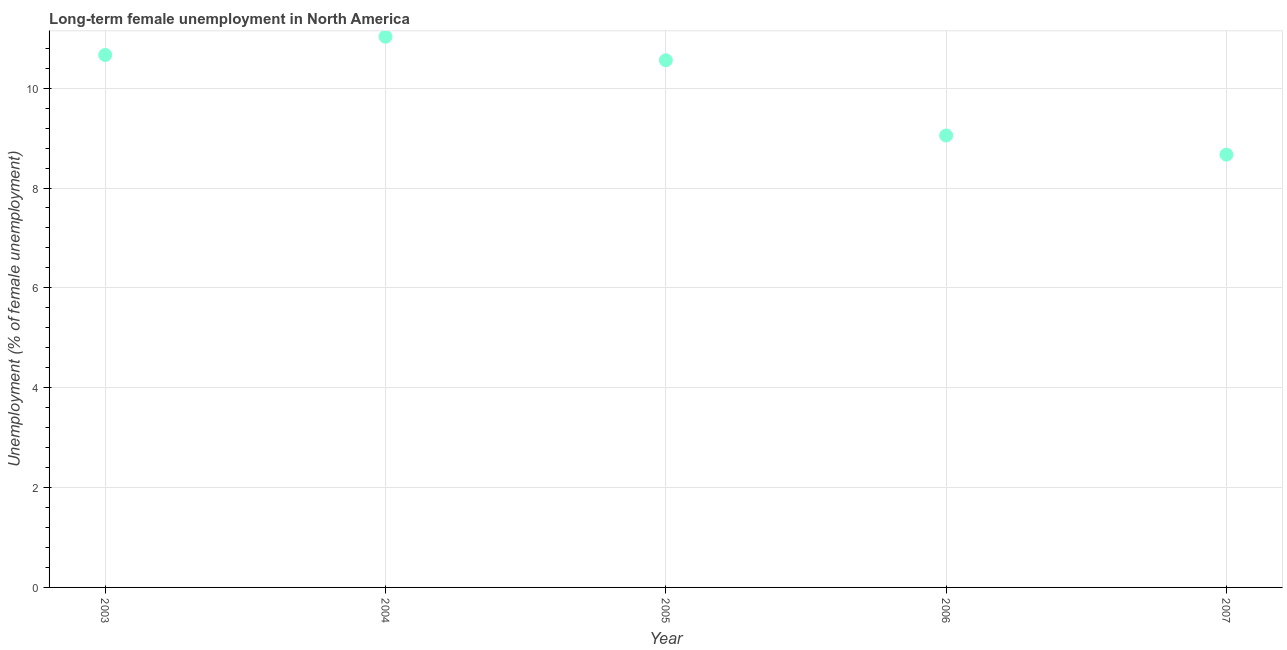What is the long-term female unemployment in 2004?
Offer a terse response. 11.03. Across all years, what is the maximum long-term female unemployment?
Your answer should be compact. 11.03. Across all years, what is the minimum long-term female unemployment?
Give a very brief answer. 8.67. In which year was the long-term female unemployment maximum?
Give a very brief answer. 2004. What is the sum of the long-term female unemployment?
Make the answer very short. 49.97. What is the difference between the long-term female unemployment in 2004 and 2005?
Provide a succinct answer. 0.47. What is the average long-term female unemployment per year?
Offer a terse response. 9.99. What is the median long-term female unemployment?
Make the answer very short. 10.56. In how many years, is the long-term female unemployment greater than 4 %?
Offer a terse response. 5. Do a majority of the years between 2007 and 2004 (inclusive) have long-term female unemployment greater than 4.4 %?
Make the answer very short. Yes. What is the ratio of the long-term female unemployment in 2004 to that in 2007?
Your response must be concise. 1.27. Is the difference between the long-term female unemployment in 2003 and 2007 greater than the difference between any two years?
Make the answer very short. No. What is the difference between the highest and the second highest long-term female unemployment?
Offer a very short reply. 0.37. Is the sum of the long-term female unemployment in 2003 and 2004 greater than the maximum long-term female unemployment across all years?
Keep it short and to the point. Yes. What is the difference between the highest and the lowest long-term female unemployment?
Your answer should be very brief. 2.36. Does the long-term female unemployment monotonically increase over the years?
Keep it short and to the point. No. How many years are there in the graph?
Provide a succinct answer. 5. What is the difference between two consecutive major ticks on the Y-axis?
Your answer should be compact. 2. Does the graph contain grids?
Provide a succinct answer. Yes. What is the title of the graph?
Provide a short and direct response. Long-term female unemployment in North America. What is the label or title of the X-axis?
Your answer should be compact. Year. What is the label or title of the Y-axis?
Give a very brief answer. Unemployment (% of female unemployment). What is the Unemployment (% of female unemployment) in 2003?
Offer a very short reply. 10.66. What is the Unemployment (% of female unemployment) in 2004?
Keep it short and to the point. 11.03. What is the Unemployment (% of female unemployment) in 2005?
Keep it short and to the point. 10.56. What is the Unemployment (% of female unemployment) in 2006?
Your answer should be very brief. 9.05. What is the Unemployment (% of female unemployment) in 2007?
Your answer should be very brief. 8.67. What is the difference between the Unemployment (% of female unemployment) in 2003 and 2004?
Offer a terse response. -0.37. What is the difference between the Unemployment (% of female unemployment) in 2003 and 2005?
Offer a terse response. 0.11. What is the difference between the Unemployment (% of female unemployment) in 2003 and 2006?
Offer a terse response. 1.61. What is the difference between the Unemployment (% of female unemployment) in 2003 and 2007?
Keep it short and to the point. 2. What is the difference between the Unemployment (% of female unemployment) in 2004 and 2005?
Give a very brief answer. 0.47. What is the difference between the Unemployment (% of female unemployment) in 2004 and 2006?
Give a very brief answer. 1.98. What is the difference between the Unemployment (% of female unemployment) in 2004 and 2007?
Give a very brief answer. 2.36. What is the difference between the Unemployment (% of female unemployment) in 2005 and 2006?
Your answer should be compact. 1.51. What is the difference between the Unemployment (% of female unemployment) in 2005 and 2007?
Keep it short and to the point. 1.89. What is the difference between the Unemployment (% of female unemployment) in 2006 and 2007?
Give a very brief answer. 0.38. What is the ratio of the Unemployment (% of female unemployment) in 2003 to that in 2005?
Ensure brevity in your answer.  1.01. What is the ratio of the Unemployment (% of female unemployment) in 2003 to that in 2006?
Give a very brief answer. 1.18. What is the ratio of the Unemployment (% of female unemployment) in 2003 to that in 2007?
Provide a succinct answer. 1.23. What is the ratio of the Unemployment (% of female unemployment) in 2004 to that in 2005?
Ensure brevity in your answer.  1.04. What is the ratio of the Unemployment (% of female unemployment) in 2004 to that in 2006?
Ensure brevity in your answer.  1.22. What is the ratio of the Unemployment (% of female unemployment) in 2004 to that in 2007?
Provide a short and direct response. 1.27. What is the ratio of the Unemployment (% of female unemployment) in 2005 to that in 2006?
Your response must be concise. 1.17. What is the ratio of the Unemployment (% of female unemployment) in 2005 to that in 2007?
Your answer should be compact. 1.22. What is the ratio of the Unemployment (% of female unemployment) in 2006 to that in 2007?
Ensure brevity in your answer.  1.04. 